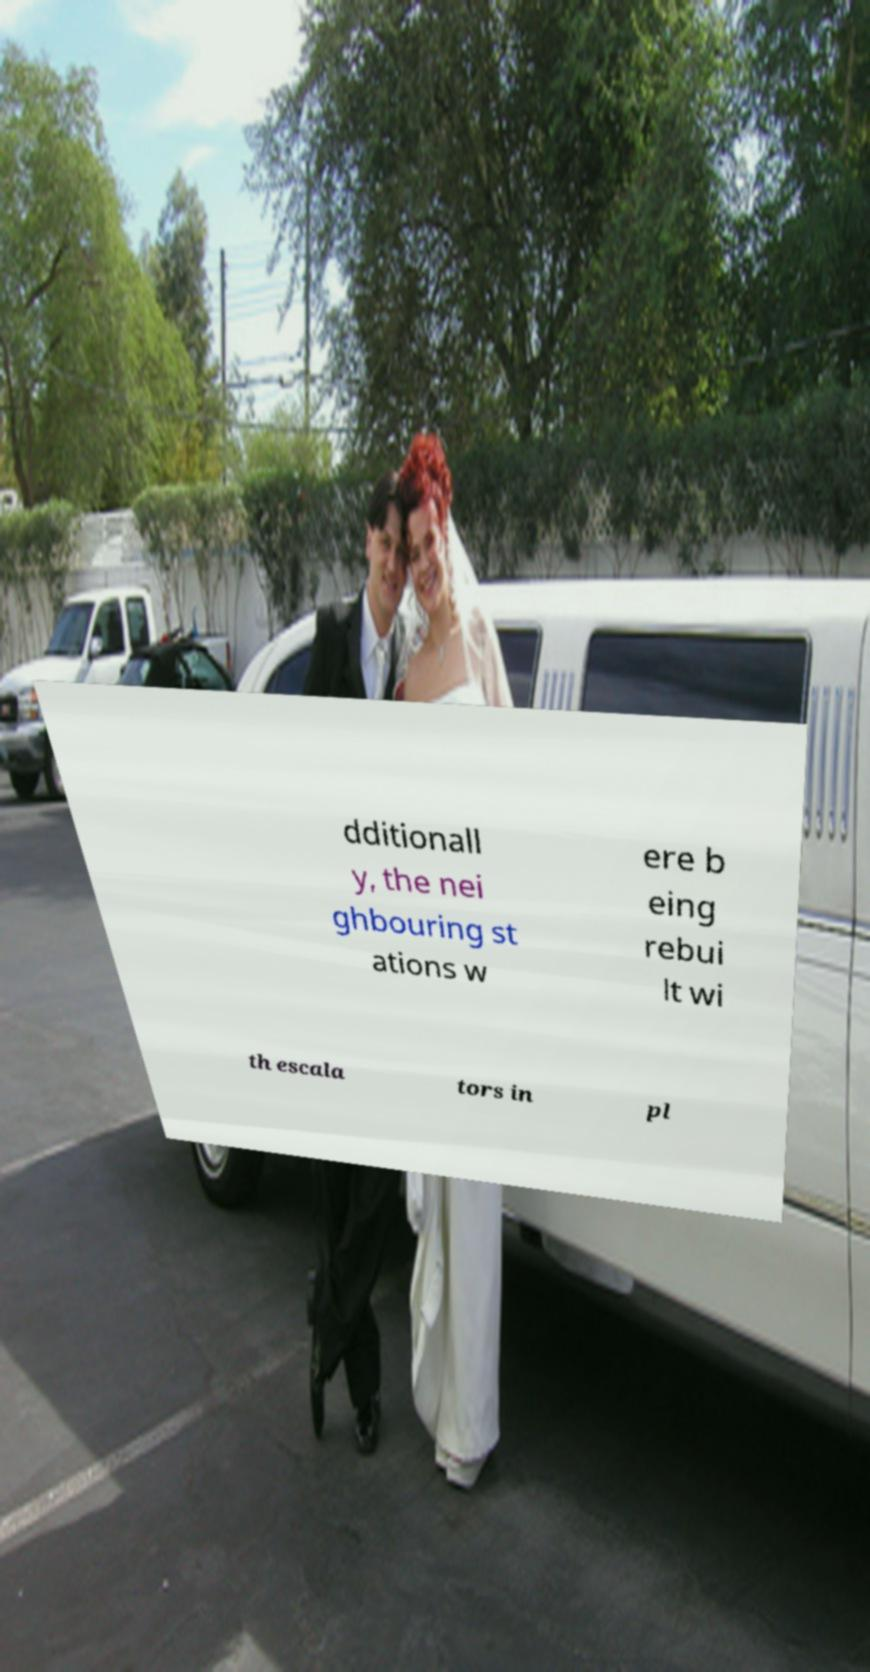I need the written content from this picture converted into text. Can you do that? dditionall y, the nei ghbouring st ations w ere b eing rebui lt wi th escala tors in pl 